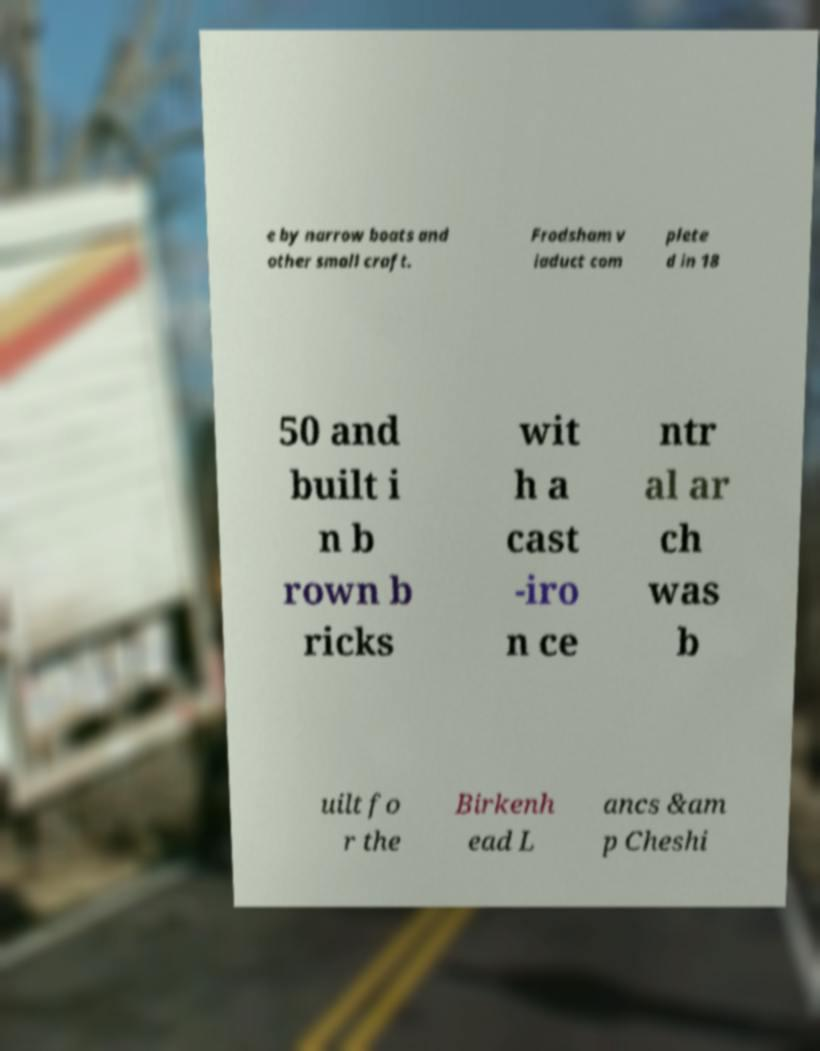Can you accurately transcribe the text from the provided image for me? e by narrow boats and other small craft. Frodsham v iaduct com plete d in 18 50 and built i n b rown b ricks wit h a cast -iro n ce ntr al ar ch was b uilt fo r the Birkenh ead L ancs &am p Cheshi 